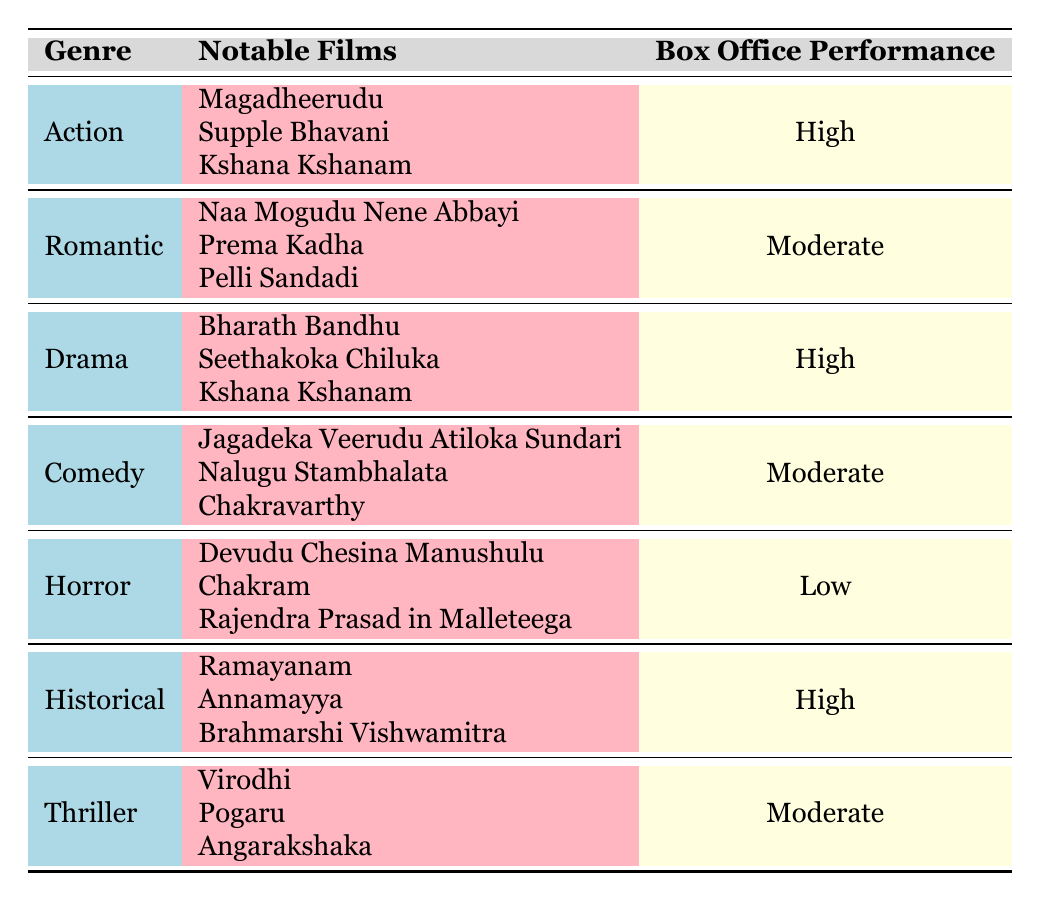What is the box office performance of the Action genre? The table indicates that the Action genre has a box office performance categorized as "High."
Answer: High Name one notable film from the Comedy genre. According to the table, one notable film from the Comedy genre is "Jagadeka Veerudu Atiloka Sundari."
Answer: Jagadeka Veerudu Atiloka Sundari How many genres have a high box office performance? There are three genres—Action, Drama, and Historical—that have a high box office performance as shown in the table.
Answer: 3 Is there any genre with low box office performance? Yes, the Horror genre has a box office performance categorized as "Low."
Answer: Yes Which genre has the most notable films listed? The genres that list the same number of notable films are Action, Romantic, Drama, Comedy, Horror, Historical, and Thriller; each has three notable films according to the table.
Answer: All genres have three notable films What is the box office performance of the Historical genre and which notable films are associated with it? The Historical genre has a box office performance of "High" and its notable films include "Ramayanam," "Annamayya," and "Brahmarshi Vishwamitra."
Answer: High; Ramayanam, Annamayya, Brahmarshi Vishwamitra Calculate how many genres have either moderate or low box office performance. The table lists Romantic, Comedy, Thriller as moderate, and Horror as low; summing these gives 4 genres with either moderate or low performance.
Answer: 4 